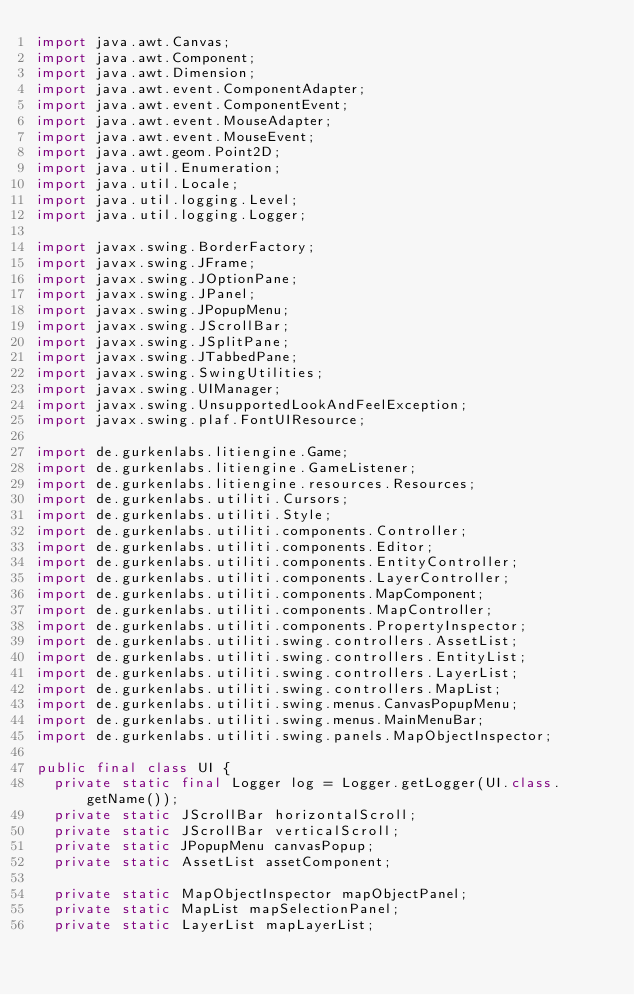Convert code to text. <code><loc_0><loc_0><loc_500><loc_500><_Java_>import java.awt.Canvas;
import java.awt.Component;
import java.awt.Dimension;
import java.awt.event.ComponentAdapter;
import java.awt.event.ComponentEvent;
import java.awt.event.MouseAdapter;
import java.awt.event.MouseEvent;
import java.awt.geom.Point2D;
import java.util.Enumeration;
import java.util.Locale;
import java.util.logging.Level;
import java.util.logging.Logger;

import javax.swing.BorderFactory;
import javax.swing.JFrame;
import javax.swing.JOptionPane;
import javax.swing.JPanel;
import javax.swing.JPopupMenu;
import javax.swing.JScrollBar;
import javax.swing.JSplitPane;
import javax.swing.JTabbedPane;
import javax.swing.SwingUtilities;
import javax.swing.UIManager;
import javax.swing.UnsupportedLookAndFeelException;
import javax.swing.plaf.FontUIResource;

import de.gurkenlabs.litiengine.Game;
import de.gurkenlabs.litiengine.GameListener;
import de.gurkenlabs.litiengine.resources.Resources;
import de.gurkenlabs.utiliti.Cursors;
import de.gurkenlabs.utiliti.Style;
import de.gurkenlabs.utiliti.components.Controller;
import de.gurkenlabs.utiliti.components.Editor;
import de.gurkenlabs.utiliti.components.EntityController;
import de.gurkenlabs.utiliti.components.LayerController;
import de.gurkenlabs.utiliti.components.MapComponent;
import de.gurkenlabs.utiliti.components.MapController;
import de.gurkenlabs.utiliti.components.PropertyInspector;
import de.gurkenlabs.utiliti.swing.controllers.AssetList;
import de.gurkenlabs.utiliti.swing.controllers.EntityList;
import de.gurkenlabs.utiliti.swing.controllers.LayerList;
import de.gurkenlabs.utiliti.swing.controllers.MapList;
import de.gurkenlabs.utiliti.swing.menus.CanvasPopupMenu;
import de.gurkenlabs.utiliti.swing.menus.MainMenuBar;
import de.gurkenlabs.utiliti.swing.panels.MapObjectInspector;

public final class UI {
  private static final Logger log = Logger.getLogger(UI.class.getName());
  private static JScrollBar horizontalScroll;
  private static JScrollBar verticalScroll;
  private static JPopupMenu canvasPopup;
  private static AssetList assetComponent;

  private static MapObjectInspector mapObjectPanel;
  private static MapList mapSelectionPanel;
  private static LayerList mapLayerList;</code> 